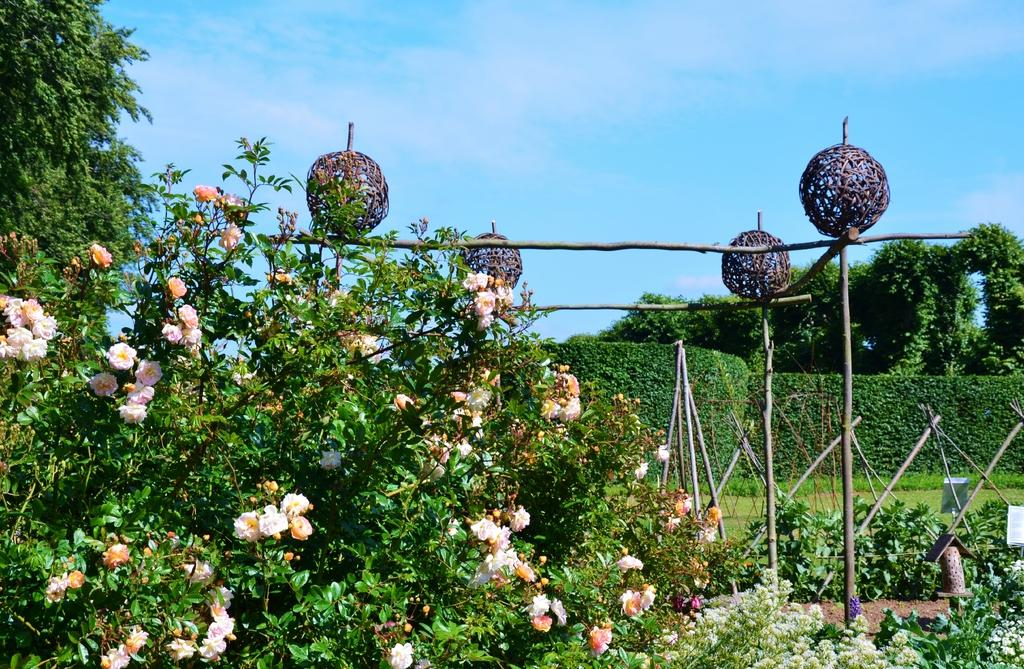What type of plants can be seen in the image? There are flowers in the image. What else can be seen in the image besides flowers? There are sticks and trees visible in the image. What is visible in the background of the image? The sky is visible in the background of the image. What can be seen in the sky? Clouds are present in the sky. What time does the clock show in the image? There is no clock present in the image. What color are the crayons in the image? There are no crayons present in the image. 